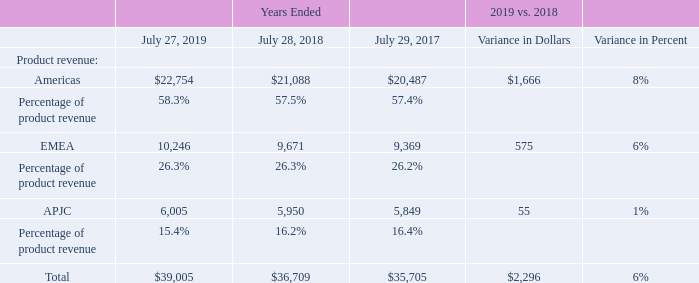Product Revenue by Segment
The following table presents the breakdown of product revenue by segment (in millions, except percentages):
Amounts may not sum and percentages may not recalculate due to rounding.
Americas Product revenue in the Americas segment increased by 8%, driven by growth in the enterprise, public sector and commercial markets. These increases were partially offset by a product revenue decline in the service provider market. From a country perspective, product revenue increased by 9% in the United States, 26% in Mexico and 6% in Canada, partially offset by a product revenue decrease of 1% in Brazil.
EMEA The increase in product revenue in the EMEA segment of 6% was driven by growth in the public sector and enterprise markets, partially offset by a decline in the service provider market. Product revenue in the commercial market was flat. Product revenue from emerging countries within EMEA increased by 9%, and product revenue for the remainder of the EMEA segment increased by 5%.
APJC Product revenue in the APJC segment increased by 1%, driven by growth in the public sector and enterprise markets, partially offset by declines in the service provider and commercial markets. From a country perspective, product revenue increased by 9% in Japan and 5% in India, partially offset by a product revenue decrease of 16% in China.
Which years does the table provide information for the breakdown of the company's product revenue by segment? 2019, 2018, 2017. What was the product revenue from Americas in 2017?
Answer scale should be: million. 20,487. What was the variance in dollars for the product revenue from EMEA for 2019 and 2018?
Answer scale should be: million. 575. What was the change in the product revenue from APJC between 2017 and 2018?
Answer scale should be: million. 5,950-5,849
Answer: 101. What was the change in the product revenue from Americas between 2017 and 2018?
Answer scale should be: million. 21,088-20,487
Answer: 601. What was the percentage change in the total revenue from all segments between 2017 and 2018?
Answer scale should be: percent. (36,709-35,705)/35,705
Answer: 2.81. 